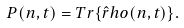Convert formula to latex. <formula><loc_0><loc_0><loc_500><loc_500>P ( n , t ) = T r \{ \hat { r } h o ( n , t ) \} .</formula> 